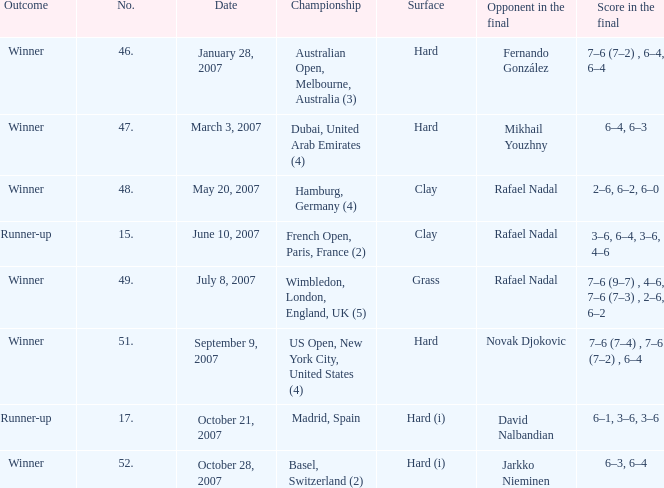The score in the final is 2–6, 6–2, 6–0, on what surface? Clay. 